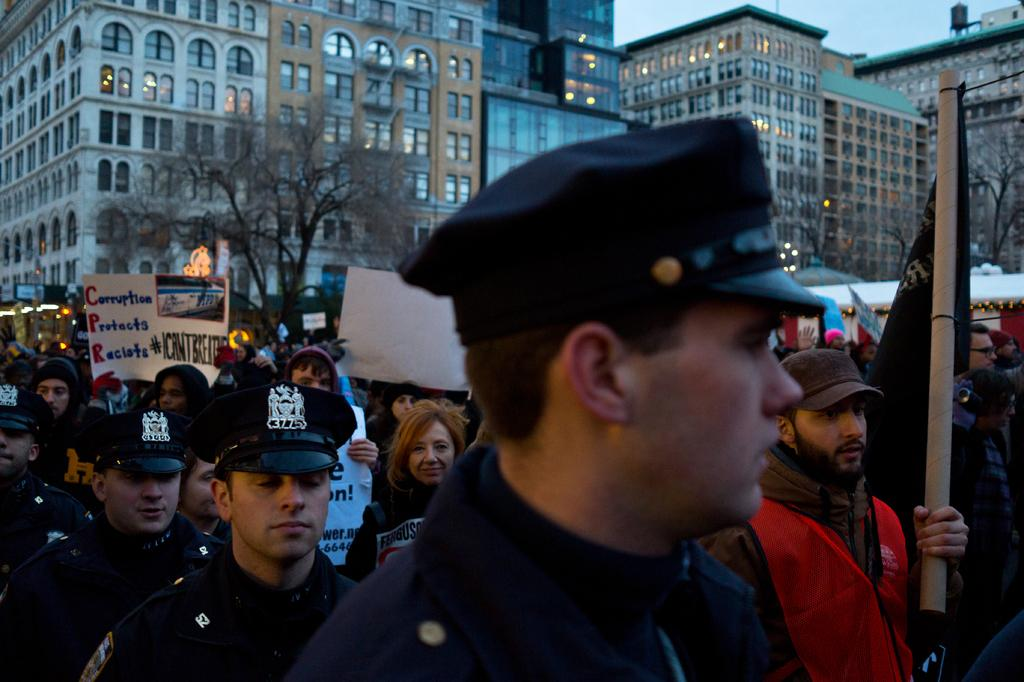How many people are in the image? There is a group of people in the image, but the exact number cannot be determined from the provided facts. What can be seen in the background of the image? There are buildings and trees in the background of the image. What type of pen is being used by the person in the image? There is no pen visible in the image. What emotion is the person in the image feeling? The provided facts do not give any information about the emotions of the people in the image. 